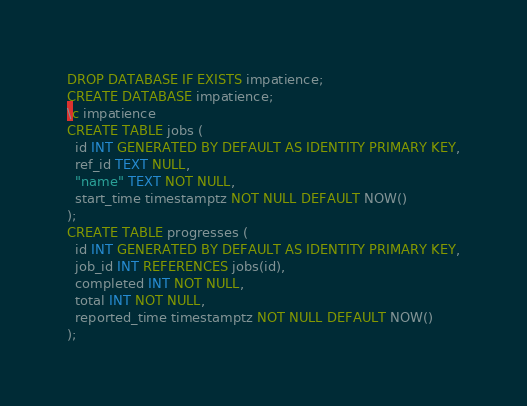<code> <loc_0><loc_0><loc_500><loc_500><_SQL_>DROP DATABASE IF EXISTS impatience;
CREATE DATABASE impatience;
\c impatience
CREATE TABLE jobs (
  id INT GENERATED BY DEFAULT AS IDENTITY PRIMARY KEY,
  ref_id TEXT NULL,
  "name" TEXT NOT NULL,
  start_time timestamptz NOT NULL DEFAULT NOW()
);
CREATE TABLE progresses (
  id INT GENERATED BY DEFAULT AS IDENTITY PRIMARY KEY,
  job_id INT REFERENCES jobs(id),
  completed INT NOT NULL,
  total INT NOT NULL,
  reported_time timestamptz NOT NULL DEFAULT NOW()
);
</code> 